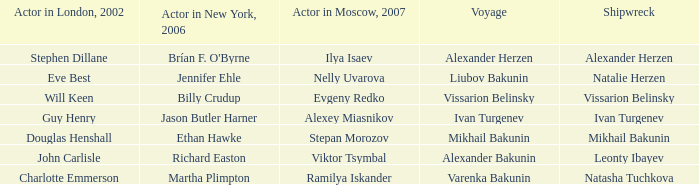Who was the Actor in the New York production in 2006 for the row with Ramilya Iskander performing in Moscow in 2007? Martha Plimpton. I'm looking to parse the entire table for insights. Could you assist me with that? {'header': ['Actor in London, 2002', 'Actor in New York, 2006', 'Actor in Moscow, 2007', 'Voyage', 'Shipwreck'], 'rows': [['Stephen Dillane', "Brían F. O'Byrne", 'Ilya Isaev', 'Alexander Herzen', 'Alexander Herzen'], ['Eve Best', 'Jennifer Ehle', 'Nelly Uvarova', 'Liubov Bakunin', 'Natalie Herzen'], ['Will Keen', 'Billy Crudup', 'Evgeny Redko', 'Vissarion Belinsky', 'Vissarion Belinsky'], ['Guy Henry', 'Jason Butler Harner', 'Alexey Miasnikov', 'Ivan Turgenev', 'Ivan Turgenev'], ['Douglas Henshall', 'Ethan Hawke', 'Stepan Morozov', 'Mikhail Bakunin', 'Mikhail Bakunin'], ['John Carlisle', 'Richard Easton', 'Viktor Tsymbal', 'Alexander Bakunin', 'Leonty Ibayev'], ['Charlotte Emmerson', 'Martha Plimpton', 'Ramilya Iskander', 'Varenka Bakunin', 'Natasha Tuchkova']]} 